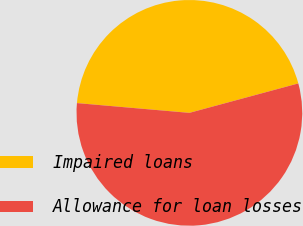Convert chart to OTSL. <chart><loc_0><loc_0><loc_500><loc_500><pie_chart><fcel>Impaired loans<fcel>Allowance for loan losses<nl><fcel>44.42%<fcel>55.58%<nl></chart> 